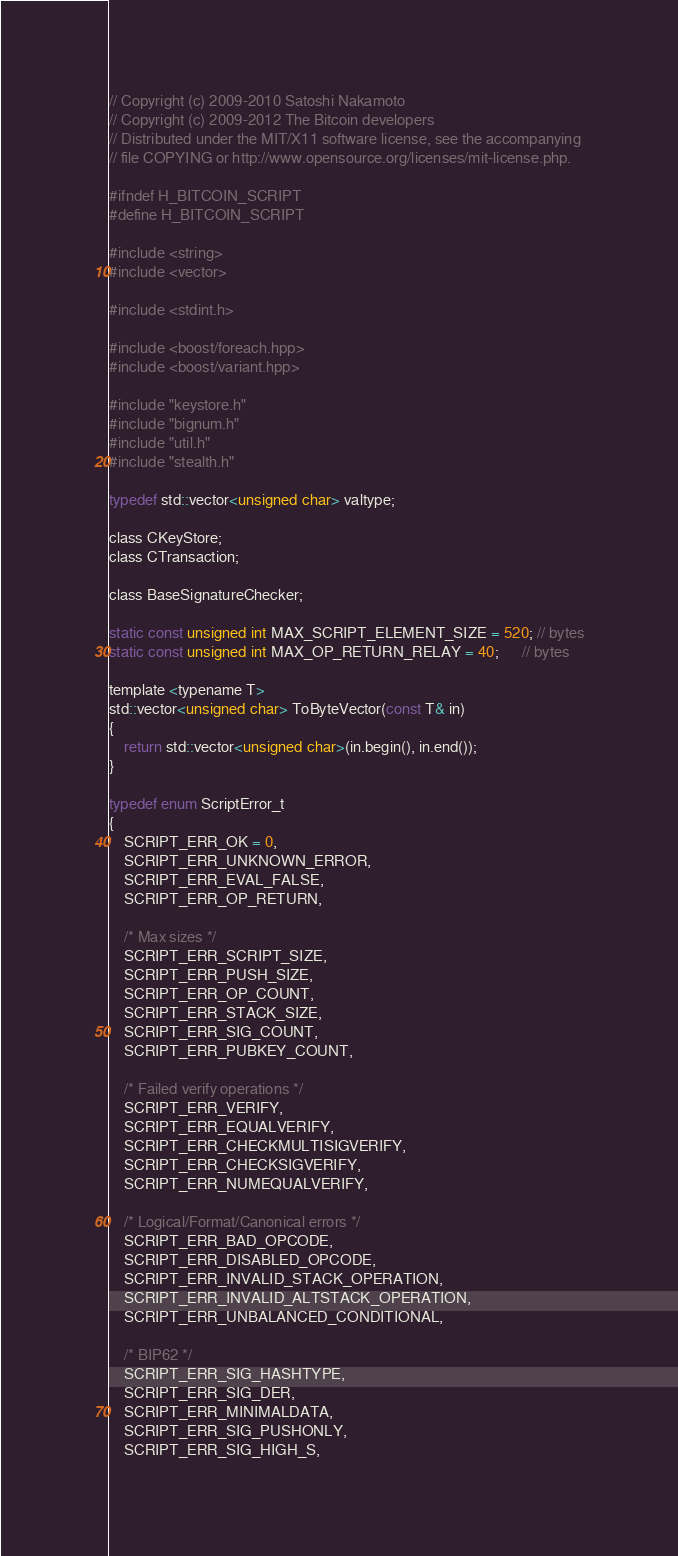Convert code to text. <code><loc_0><loc_0><loc_500><loc_500><_C_>// Copyright (c) 2009-2010 Satoshi Nakamoto
// Copyright (c) 2009-2012 The Bitcoin developers
// Distributed under the MIT/X11 software license, see the accompanying
// file COPYING or http://www.opensource.org/licenses/mit-license.php.

#ifndef H_BITCOIN_SCRIPT
#define H_BITCOIN_SCRIPT

#include <string>
#include <vector>

#include <stdint.h>

#include <boost/foreach.hpp>
#include <boost/variant.hpp>

#include "keystore.h"
#include "bignum.h"
#include "util.h"
#include "stealth.h"

typedef std::vector<unsigned char> valtype;

class CKeyStore;
class CTransaction;

class BaseSignatureChecker;

static const unsigned int MAX_SCRIPT_ELEMENT_SIZE = 520; // bytes
static const unsigned int MAX_OP_RETURN_RELAY = 40;      // bytes

template <typename T>
std::vector<unsigned char> ToByteVector(const T& in)
{
    return std::vector<unsigned char>(in.begin(), in.end());
}

typedef enum ScriptError_t
{
    SCRIPT_ERR_OK = 0,
    SCRIPT_ERR_UNKNOWN_ERROR,
    SCRIPT_ERR_EVAL_FALSE,
    SCRIPT_ERR_OP_RETURN,

    /* Max sizes */
    SCRIPT_ERR_SCRIPT_SIZE,
    SCRIPT_ERR_PUSH_SIZE,
    SCRIPT_ERR_OP_COUNT,
    SCRIPT_ERR_STACK_SIZE,
    SCRIPT_ERR_SIG_COUNT,
    SCRIPT_ERR_PUBKEY_COUNT,

    /* Failed verify operations */
    SCRIPT_ERR_VERIFY,
    SCRIPT_ERR_EQUALVERIFY,
    SCRIPT_ERR_CHECKMULTISIGVERIFY,
    SCRIPT_ERR_CHECKSIGVERIFY,
    SCRIPT_ERR_NUMEQUALVERIFY,

    /* Logical/Format/Canonical errors */
    SCRIPT_ERR_BAD_OPCODE,
    SCRIPT_ERR_DISABLED_OPCODE,
    SCRIPT_ERR_INVALID_STACK_OPERATION,
    SCRIPT_ERR_INVALID_ALTSTACK_OPERATION,
    SCRIPT_ERR_UNBALANCED_CONDITIONAL,

    /* BIP62 */
    SCRIPT_ERR_SIG_HASHTYPE,
    SCRIPT_ERR_SIG_DER,
    SCRIPT_ERR_MINIMALDATA,
    SCRIPT_ERR_SIG_PUSHONLY,
    SCRIPT_ERR_SIG_HIGH_S,</code> 